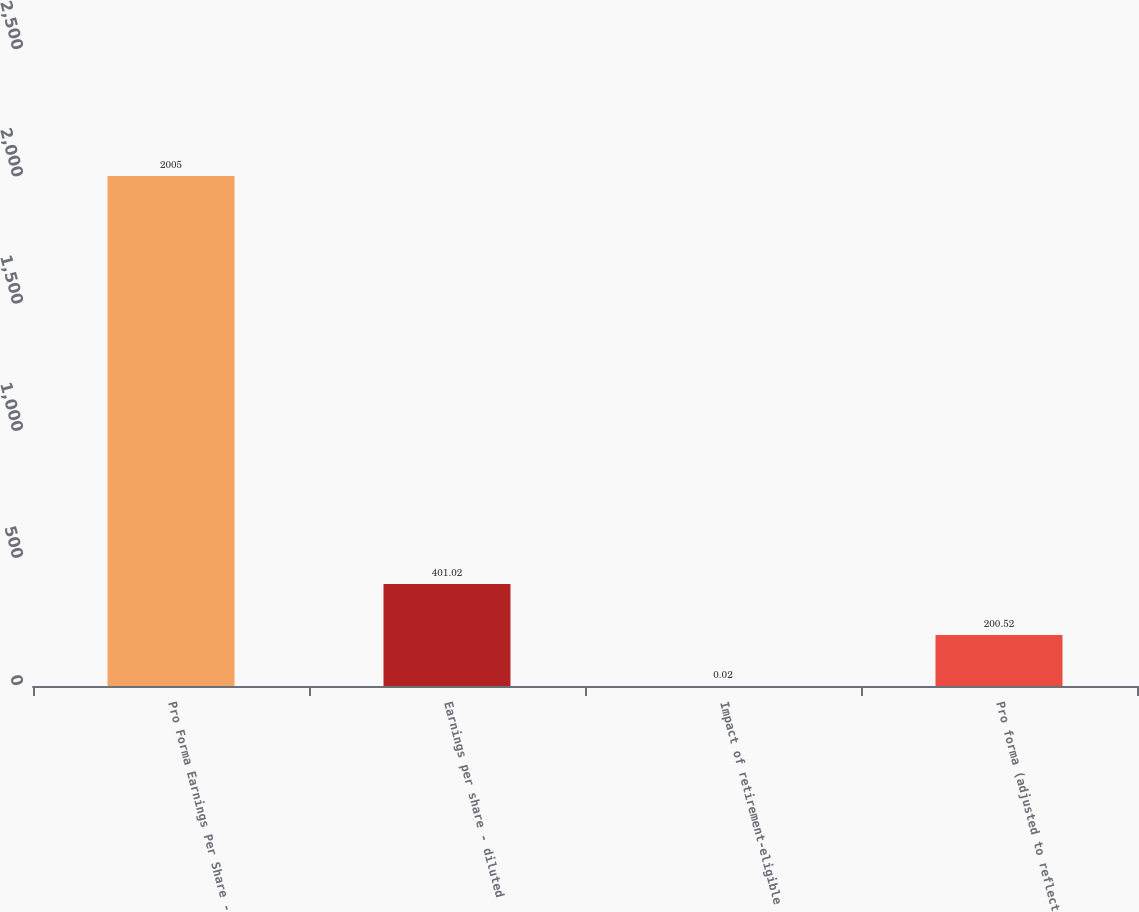<chart> <loc_0><loc_0><loc_500><loc_500><bar_chart><fcel>Pro Forma Earnings Per Share -<fcel>Earnings per share - diluted<fcel>Impact of retirement-eligible<fcel>Pro forma (adjusted to reflect<nl><fcel>2005<fcel>401.02<fcel>0.02<fcel>200.52<nl></chart> 